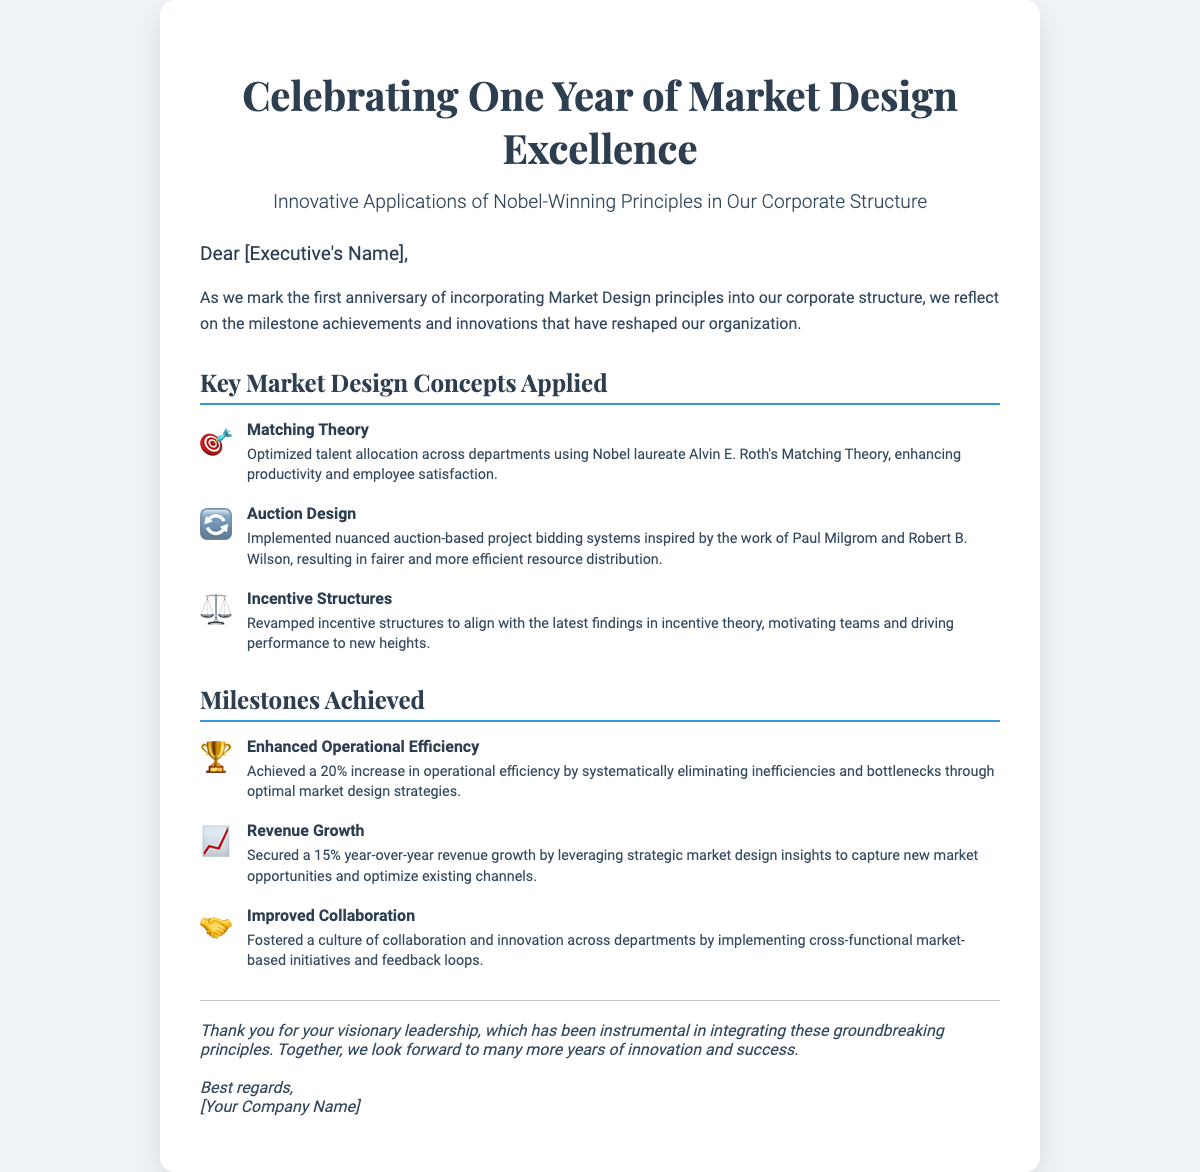What is the title of the card? The title is displayed prominently at the top of the card, stating the occasion being celebrated.
Answer: Celebrating One Year of Market Design Excellence Who is the card addressed to? The greeting mentions a placeholder for the recipient's name, which is typically personal to the executive.
Answer: [Executive's Name] What concept is represented by the icon of a target? This icon symbolizes a specific market design principle that has been applied within the organization.
Answer: Matching Theory What percentage increase in operational efficiency was achieved? The document lists specific milestones and achievements, including operational efficiency improvements.
Answer: 20% Which year-over-year revenue growth percentage is mentioned? The growth percentage is provided as part of the revenue growth milestone, indicating the company's performance.
Answer: 15% What is one of the improvements in collaboration mentioned? The details in the milestones section highlight various aspects of team dynamics and collaboration.
Answer: Improved Collaboration What framework inspired the auction-based project bidding systems? This is stated alongside its associated researchers in the item description under market design principles.
Answer: Paul Milgrom and Robert B. Wilson What does the closing paragraph acknowledge? It summarizes the leadership role in these initiatives and expresses a sentiment about future collaboration and success.
Answer: Visionary leadership 